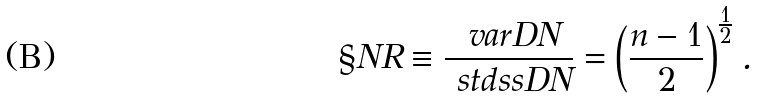Convert formula to latex. <formula><loc_0><loc_0><loc_500><loc_500>\S N R \equiv \frac { \ v a r D N } { \ s t d s s D N } = \left ( \frac { n - 1 } { 2 } \right ) ^ { \frac { 1 } { 2 } } .</formula> 